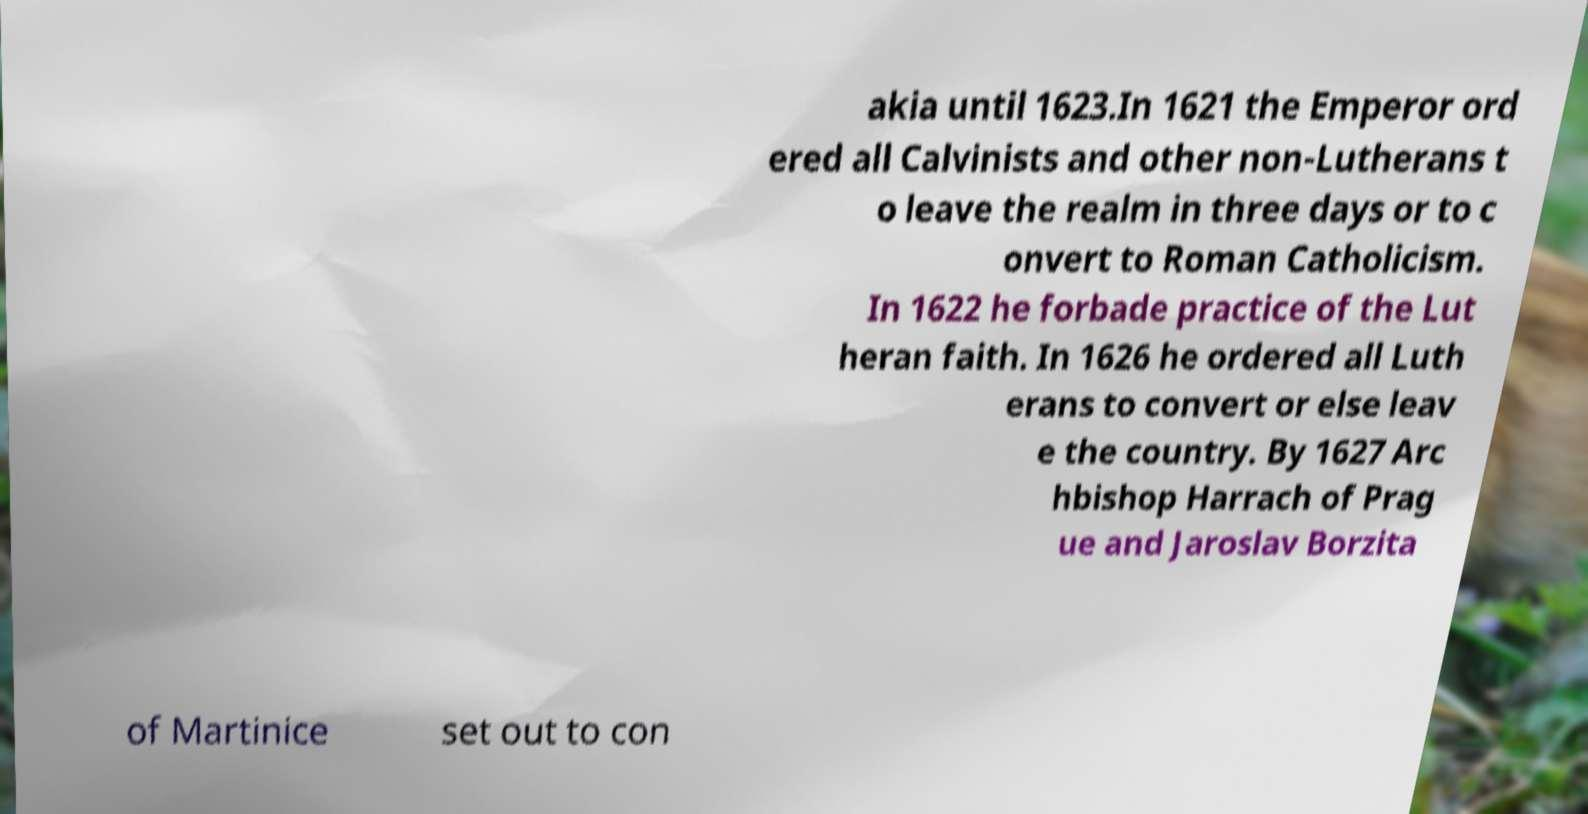Could you assist in decoding the text presented in this image and type it out clearly? akia until 1623.In 1621 the Emperor ord ered all Calvinists and other non-Lutherans t o leave the realm in three days or to c onvert to Roman Catholicism. In 1622 he forbade practice of the Lut heran faith. In 1626 he ordered all Luth erans to convert or else leav e the country. By 1627 Arc hbishop Harrach of Prag ue and Jaroslav Borzita of Martinice set out to con 